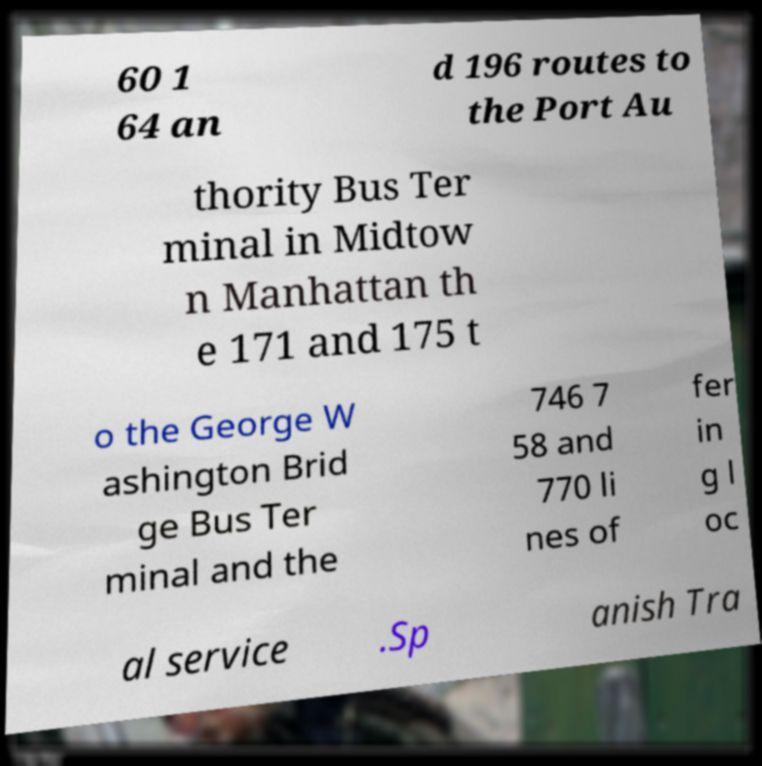There's text embedded in this image that I need extracted. Can you transcribe it verbatim? 60 1 64 an d 196 routes to the Port Au thority Bus Ter minal in Midtow n Manhattan th e 171 and 175 t o the George W ashington Brid ge Bus Ter minal and the 746 7 58 and 770 li nes of fer in g l oc al service .Sp anish Tra 